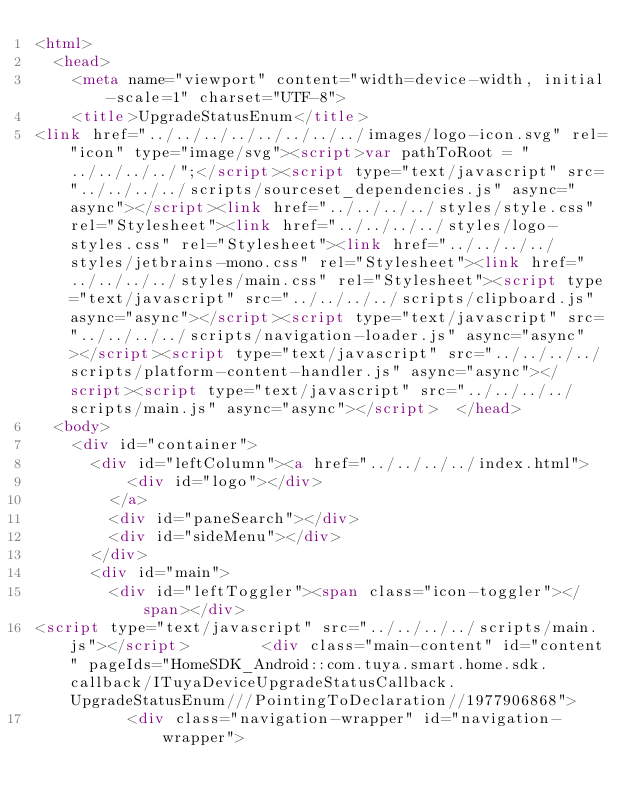<code> <loc_0><loc_0><loc_500><loc_500><_HTML_><html>
  <head>
    <meta name="viewport" content="width=device-width, initial-scale=1" charset="UTF-8">
    <title>UpgradeStatusEnum</title>
<link href="../../../../../../../../images/logo-icon.svg" rel="icon" type="image/svg"><script>var pathToRoot = "../../../../";</script><script type="text/javascript" src="../../../../scripts/sourceset_dependencies.js" async="async"></script><link href="../../../../styles/style.css" rel="Stylesheet"><link href="../../../../styles/logo-styles.css" rel="Stylesheet"><link href="../../../../styles/jetbrains-mono.css" rel="Stylesheet"><link href="../../../../styles/main.css" rel="Stylesheet"><script type="text/javascript" src="../../../../scripts/clipboard.js" async="async"></script><script type="text/javascript" src="../../../../scripts/navigation-loader.js" async="async"></script><script type="text/javascript" src="../../../../scripts/platform-content-handler.js" async="async"></script><script type="text/javascript" src="../../../../scripts/main.js" async="async"></script>  </head>
  <body>
    <div id="container">
      <div id="leftColumn"><a href="../../../../index.html">
          <div id="logo"></div>
        </a>
        <div id="paneSearch"></div>
        <div id="sideMenu"></div>
      </div>
      <div id="main">
        <div id="leftToggler"><span class="icon-toggler"></span></div>
<script type="text/javascript" src="../../../../scripts/main.js"></script>        <div class="main-content" id="content" pageIds="HomeSDK_Android::com.tuya.smart.home.sdk.callback/ITuyaDeviceUpgradeStatusCallback.UpgradeStatusEnum///PointingToDeclaration//1977906868">
          <div class="navigation-wrapper" id="navigation-wrapper"></code> 